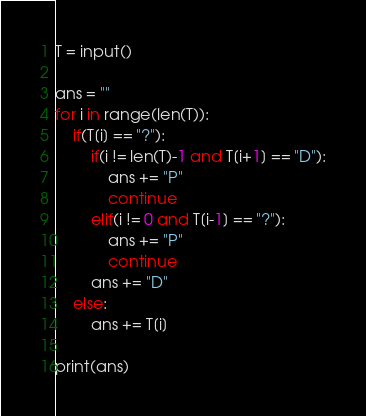Convert code to text. <code><loc_0><loc_0><loc_500><loc_500><_Python_>T = input()

ans = ""
for i in range(len(T)):
    if(T[i] == "?"):
        if(i != len(T)-1 and T[i+1] == "D"):
            ans += "P"
            continue
        elif(i != 0 and T[i-1] == "?"):
            ans += "P"
            continue
        ans += "D"
    else:
        ans += T[i]
    
print(ans)</code> 